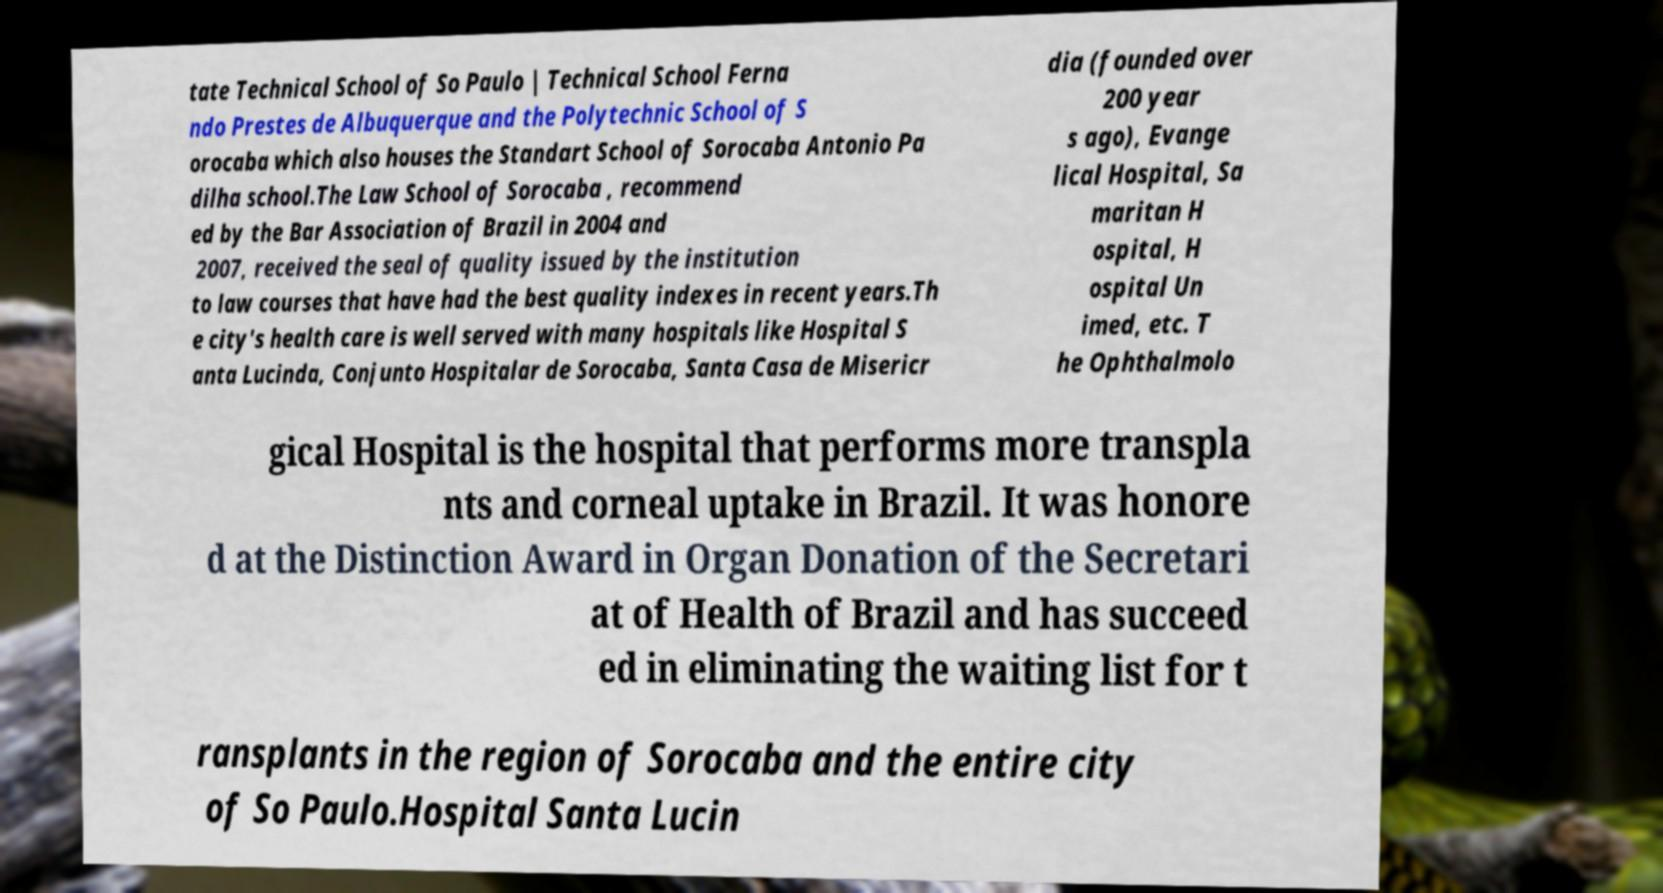For documentation purposes, I need the text within this image transcribed. Could you provide that? tate Technical School of So Paulo | Technical School Ferna ndo Prestes de Albuquerque and the Polytechnic School of S orocaba which also houses the Standart School of Sorocaba Antonio Pa dilha school.The Law School of Sorocaba , recommend ed by the Bar Association of Brazil in 2004 and 2007, received the seal of quality issued by the institution to law courses that have had the best quality indexes in recent years.Th e city's health care is well served with many hospitals like Hospital S anta Lucinda, Conjunto Hospitalar de Sorocaba, Santa Casa de Misericr dia (founded over 200 year s ago), Evange lical Hospital, Sa maritan H ospital, H ospital Un imed, etc. T he Ophthalmolo gical Hospital is the hospital that performs more transpla nts and corneal uptake in Brazil. It was honore d at the Distinction Award in Organ Donation of the Secretari at of Health of Brazil and has succeed ed in eliminating the waiting list for t ransplants in the region of Sorocaba and the entire city of So Paulo.Hospital Santa Lucin 